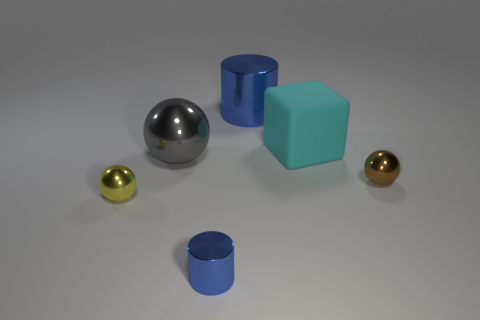Do the cyan object and the blue object that is behind the gray ball have the same material?
Offer a very short reply. No. Is there anything else that has the same color as the large cylinder?
Give a very brief answer. Yes. How many things are shiny objects that are to the left of the cyan thing or tiny objects on the right side of the large cyan cube?
Offer a terse response. 5. There is a metallic thing that is right of the gray ball and in front of the brown thing; what is its shape?
Your response must be concise. Cylinder. There is a tiny metallic ball right of the gray shiny object; how many spheres are left of it?
Your response must be concise. 2. Are there any other things that are made of the same material as the large gray sphere?
Offer a terse response. Yes. How many objects are blue objects on the right side of the small blue cylinder or tiny blue metal things?
Provide a succinct answer. 2. There is a blue cylinder that is behind the big cyan object; how big is it?
Your answer should be very brief. Large. What is the material of the tiny yellow sphere?
Offer a very short reply. Metal. What shape is the big metal thing to the left of the cylinder that is in front of the yellow metallic ball?
Your answer should be very brief. Sphere. 